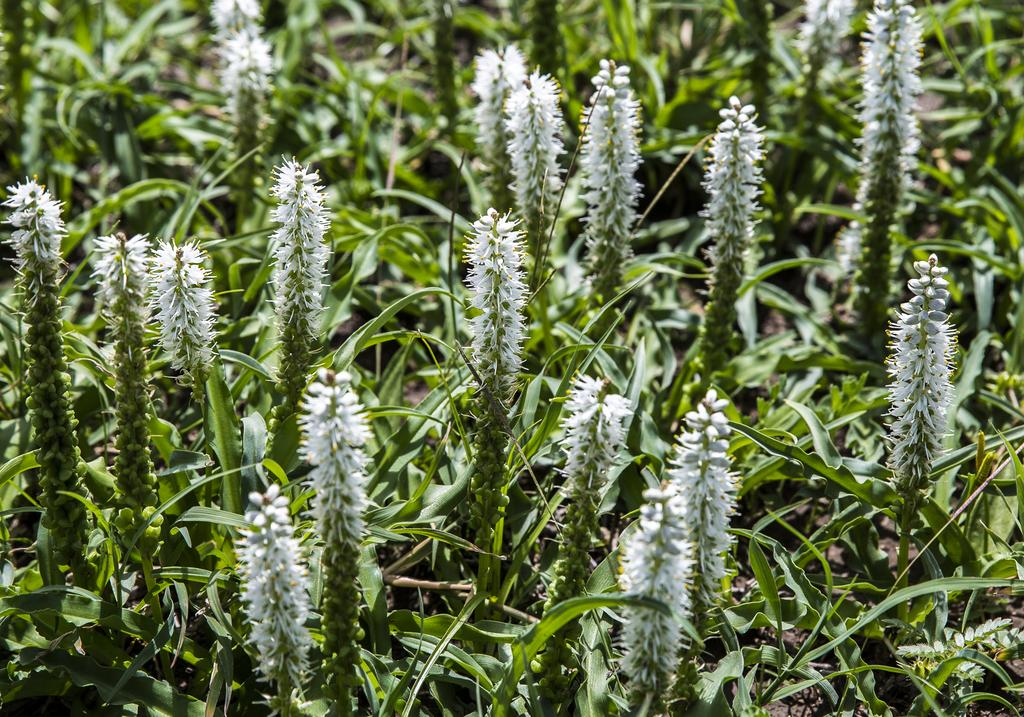What is the primary subject of the image? The primary subject of the image is many plants. Can you describe the appearance of the plants? Unfortunately, the appearance of the plants cannot be described with the given facts. What else is visible in the image besides the plants? White-colored grains are present in front of the plants. What type of hair can be seen on the plants in the image? There is no hair present on the plants in the image, as plants do not have hair. 